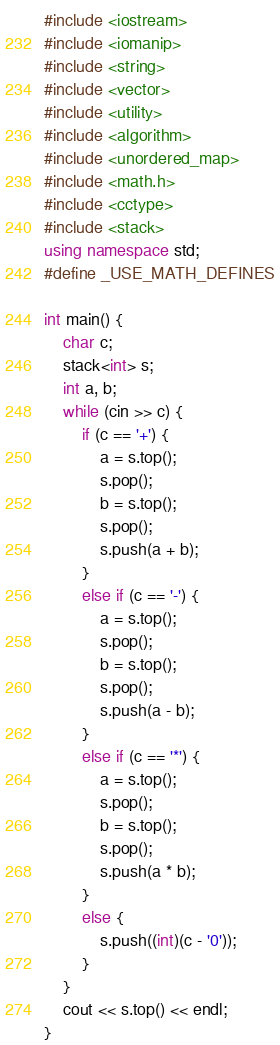Convert code to text. <code><loc_0><loc_0><loc_500><loc_500><_C++_>#include <iostream>
#include <iomanip>
#include <string>
#include <vector>
#include <utility>
#include <algorithm>
#include <unordered_map>
#include <math.h>
#include <cctype>
#include <stack>
using namespace std;
#define _USE_MATH_DEFINES

int main() {
	char c;
	stack<int> s;
	int a, b;
	while (cin >> c) {
		if (c == '+') {
			a = s.top();
			s.pop();
			b = s.top();
			s.pop();
			s.push(a + b);
		}
		else if (c == '-') {
			a = s.top();
			s.pop();
			b = s.top();
			s.pop();
			s.push(a - b);
		}
		else if (c == '*') {
			a = s.top();
			s.pop();
			b = s.top();
			s.pop();
			s.push(a * b);
		}
		else {
			s.push((int)(c - '0'));
		}
	}
	cout << s.top() << endl;
}</code> 